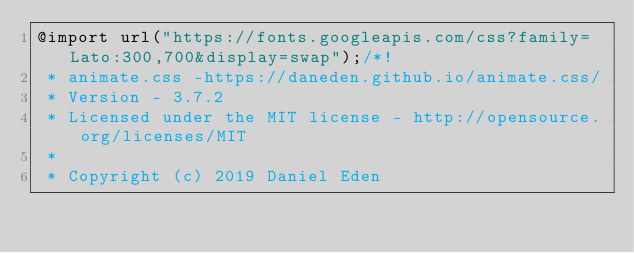Convert code to text. <code><loc_0><loc_0><loc_500><loc_500><_CSS_>@import url("https://fonts.googleapis.com/css?family=Lato:300,700&display=swap");/*!
 * animate.css -https://daneden.github.io/animate.css/
 * Version - 3.7.2
 * Licensed under the MIT license - http://opensource.org/licenses/MIT
 *
 * Copyright (c) 2019 Daniel Eden</code> 